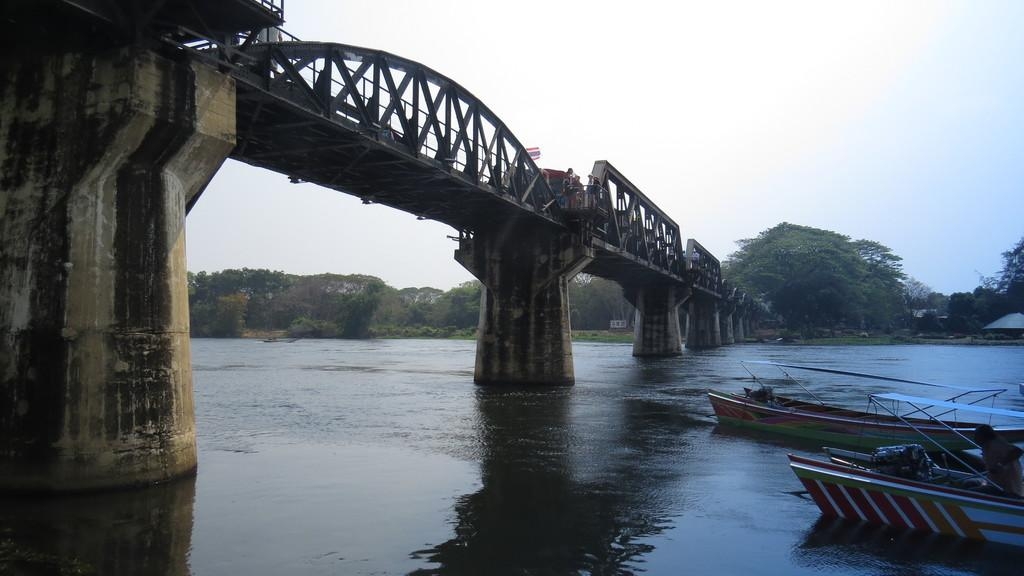What is on the water in the image? There are boats on the water in the image. What structure can be seen in the image? There is a bridge in the image. What type of vegetation is visible in the background of the image? There are trees visible in the background of the image. What else can be seen in the background of the image? The sky is visible in the background of the image. What type of discovery was made while cooking the boats in the image? There are no boats being cooked in the image, and no discoveries are mentioned or depicted. 